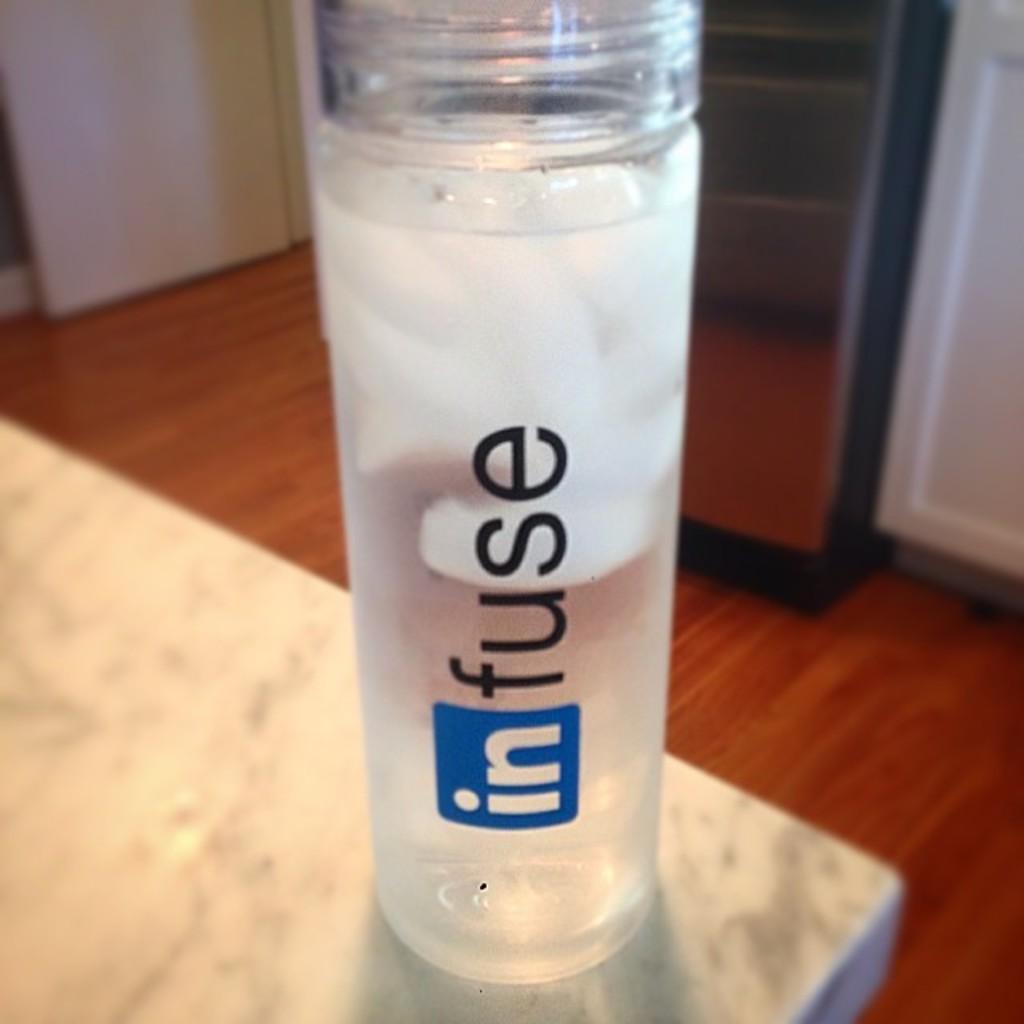Can you describe this image briefly? In this image I can see a bottle on the white color surface. Back I can see few objects on the brown color surface. 